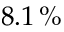Convert formula to latex. <formula><loc_0><loc_0><loc_500><loc_500>8 . 1 \, \%</formula> 